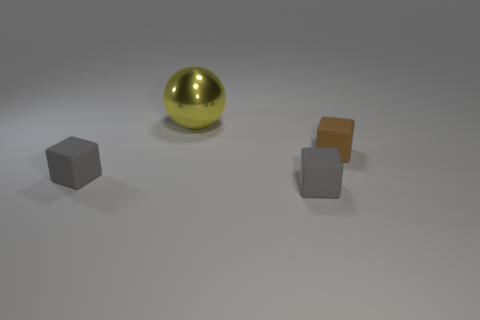Are there any other things that are the same size as the yellow metallic thing?
Keep it short and to the point. No. There is a thing that is behind the small brown thing; what size is it?
Your response must be concise. Large. Are there any other things that have the same shape as the big yellow object?
Keep it short and to the point. No. Is the number of yellow metal balls behind the shiny object the same as the number of small gray cubes?
Keep it short and to the point. No. There is a big yellow shiny object; are there any small things behind it?
Ensure brevity in your answer.  No. Is the shape of the large metal object the same as the thing on the left side of the big sphere?
Your response must be concise. No. The big ball is what color?
Your answer should be very brief. Yellow. Do the large object and the small gray cube that is on the right side of the yellow metallic thing have the same material?
Provide a short and direct response. No. How many matte things are both on the right side of the big yellow metal sphere and in front of the brown matte cube?
Give a very brief answer. 1. Is there a tiny matte thing in front of the small gray block on the right side of the object behind the brown cube?
Ensure brevity in your answer.  No. 